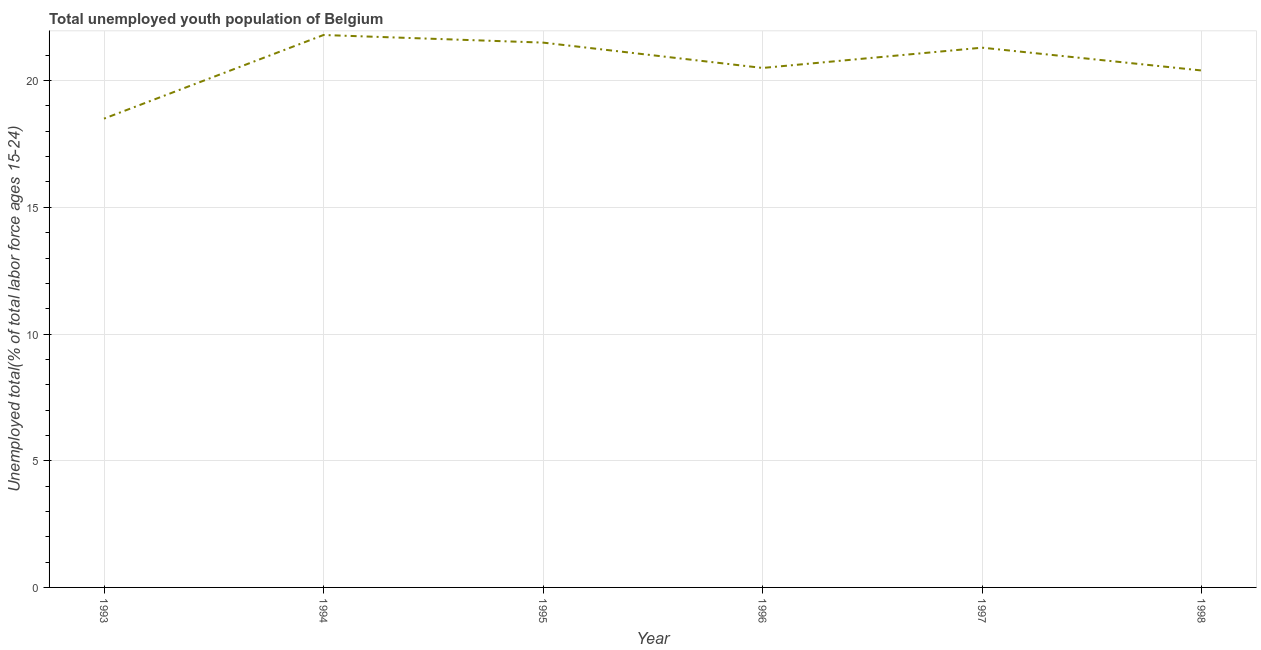What is the unemployed youth in 1997?
Your response must be concise. 21.3. Across all years, what is the maximum unemployed youth?
Your answer should be compact. 21.8. Across all years, what is the minimum unemployed youth?
Your answer should be compact. 18.5. In which year was the unemployed youth maximum?
Ensure brevity in your answer.  1994. In which year was the unemployed youth minimum?
Keep it short and to the point. 1993. What is the sum of the unemployed youth?
Provide a succinct answer. 124. What is the difference between the unemployed youth in 1995 and 1998?
Offer a terse response. 1.1. What is the average unemployed youth per year?
Your answer should be compact. 20.67. What is the median unemployed youth?
Ensure brevity in your answer.  20.9. Do a majority of the years between 1998 and 1994 (inclusive) have unemployed youth greater than 6 %?
Offer a terse response. Yes. What is the ratio of the unemployed youth in 1993 to that in 1997?
Give a very brief answer. 0.87. What is the difference between the highest and the second highest unemployed youth?
Give a very brief answer. 0.3. Is the sum of the unemployed youth in 1995 and 1998 greater than the maximum unemployed youth across all years?
Offer a very short reply. Yes. What is the difference between the highest and the lowest unemployed youth?
Offer a very short reply. 3.3. Does the unemployed youth monotonically increase over the years?
Provide a succinct answer. No. How many years are there in the graph?
Your response must be concise. 6. Does the graph contain any zero values?
Give a very brief answer. No. What is the title of the graph?
Provide a short and direct response. Total unemployed youth population of Belgium. What is the label or title of the Y-axis?
Your answer should be very brief. Unemployed total(% of total labor force ages 15-24). What is the Unemployed total(% of total labor force ages 15-24) in 1994?
Make the answer very short. 21.8. What is the Unemployed total(% of total labor force ages 15-24) of 1995?
Provide a short and direct response. 21.5. What is the Unemployed total(% of total labor force ages 15-24) of 1997?
Offer a very short reply. 21.3. What is the Unemployed total(% of total labor force ages 15-24) of 1998?
Your answer should be very brief. 20.4. What is the difference between the Unemployed total(% of total labor force ages 15-24) in 1993 and 1994?
Provide a succinct answer. -3.3. What is the difference between the Unemployed total(% of total labor force ages 15-24) in 1993 and 1996?
Provide a succinct answer. -2. What is the difference between the Unemployed total(% of total labor force ages 15-24) in 1993 and 1997?
Offer a very short reply. -2.8. What is the difference between the Unemployed total(% of total labor force ages 15-24) in 1994 and 1996?
Your answer should be compact. 1.3. What is the difference between the Unemployed total(% of total labor force ages 15-24) in 1994 and 1997?
Give a very brief answer. 0.5. What is the difference between the Unemployed total(% of total labor force ages 15-24) in 1995 and 1996?
Your answer should be compact. 1. What is the difference between the Unemployed total(% of total labor force ages 15-24) in 1995 and 1998?
Your response must be concise. 1.1. What is the difference between the Unemployed total(% of total labor force ages 15-24) in 1996 and 1998?
Offer a terse response. 0.1. What is the difference between the Unemployed total(% of total labor force ages 15-24) in 1997 and 1998?
Your answer should be compact. 0.9. What is the ratio of the Unemployed total(% of total labor force ages 15-24) in 1993 to that in 1994?
Ensure brevity in your answer.  0.85. What is the ratio of the Unemployed total(% of total labor force ages 15-24) in 1993 to that in 1995?
Provide a succinct answer. 0.86. What is the ratio of the Unemployed total(% of total labor force ages 15-24) in 1993 to that in 1996?
Provide a succinct answer. 0.9. What is the ratio of the Unemployed total(% of total labor force ages 15-24) in 1993 to that in 1997?
Make the answer very short. 0.87. What is the ratio of the Unemployed total(% of total labor force ages 15-24) in 1993 to that in 1998?
Provide a short and direct response. 0.91. What is the ratio of the Unemployed total(% of total labor force ages 15-24) in 1994 to that in 1995?
Make the answer very short. 1.01. What is the ratio of the Unemployed total(% of total labor force ages 15-24) in 1994 to that in 1996?
Offer a terse response. 1.06. What is the ratio of the Unemployed total(% of total labor force ages 15-24) in 1994 to that in 1998?
Your answer should be very brief. 1.07. What is the ratio of the Unemployed total(% of total labor force ages 15-24) in 1995 to that in 1996?
Offer a terse response. 1.05. What is the ratio of the Unemployed total(% of total labor force ages 15-24) in 1995 to that in 1998?
Keep it short and to the point. 1.05. What is the ratio of the Unemployed total(% of total labor force ages 15-24) in 1996 to that in 1997?
Offer a very short reply. 0.96. What is the ratio of the Unemployed total(% of total labor force ages 15-24) in 1996 to that in 1998?
Your answer should be very brief. 1. What is the ratio of the Unemployed total(% of total labor force ages 15-24) in 1997 to that in 1998?
Offer a very short reply. 1.04. 